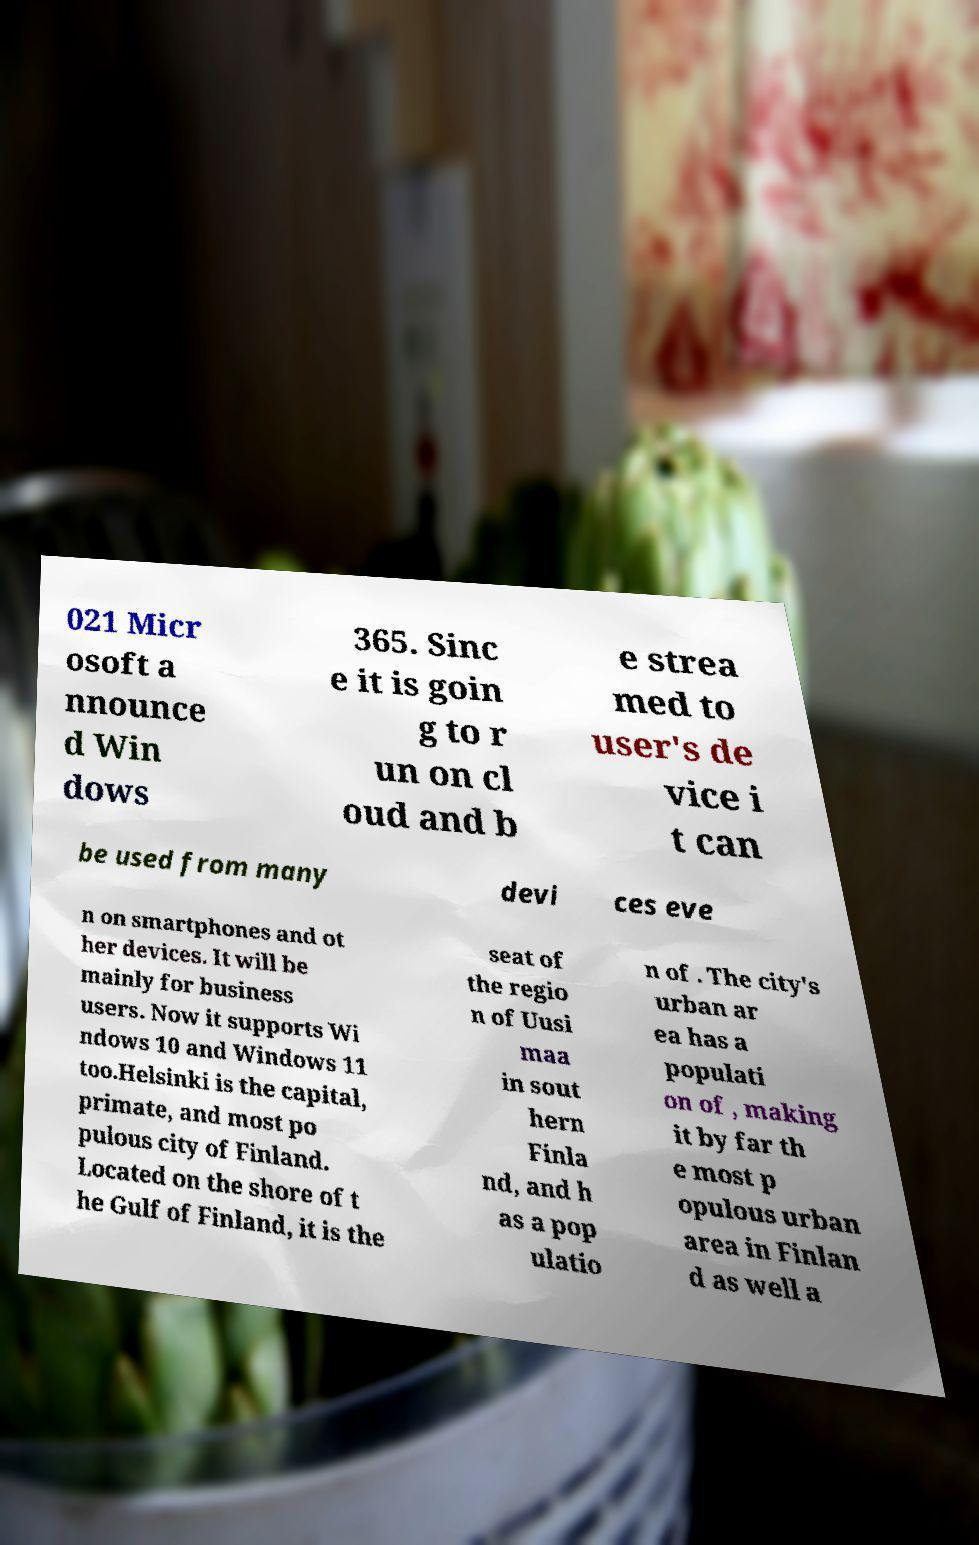Can you accurately transcribe the text from the provided image for me? 021 Micr osoft a nnounce d Win dows 365. Sinc e it is goin g to r un on cl oud and b e strea med to user's de vice i t can be used from many devi ces eve n on smartphones and ot her devices. It will be mainly for business users. Now it supports Wi ndows 10 and Windows 11 too.Helsinki is the capital, primate, and most po pulous city of Finland. Located on the shore of t he Gulf of Finland, it is the seat of the regio n of Uusi maa in sout hern Finla nd, and h as a pop ulatio n of . The city's urban ar ea has a populati on of , making it by far th e most p opulous urban area in Finlan d as well a 